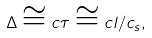Convert formula to latex. <formula><loc_0><loc_0><loc_500><loc_500>\Delta \cong c \tau \cong c l / c _ { s } ,</formula> 